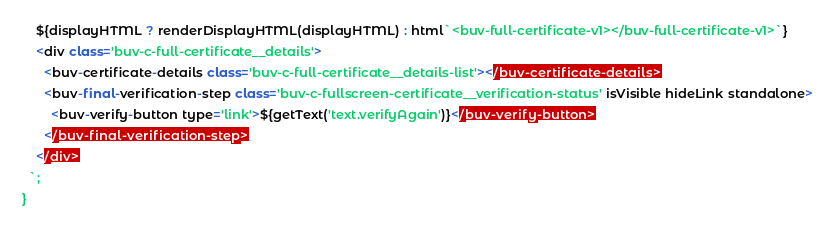Convert code to text. <code><loc_0><loc_0><loc_500><loc_500><_JavaScript_>    ${displayHTML ? renderDisplayHTML(displayHTML) : html`<buv-full-certificate-v1></buv-full-certificate-v1>`}
    <div class='buv-c-full-certificate__details'>
      <buv-certificate-details class='buv-c-full-certificate__details-list'></buv-certificate-details>
      <buv-final-verification-step class='buv-c-fullscreen-certificate__verification-status' isVisible hideLink standalone>
        <buv-verify-button type='link'>${getText('text.verifyAgain')}</buv-verify-button>
      </buv-final-verification-step>
    </div>
  `;
}
</code> 